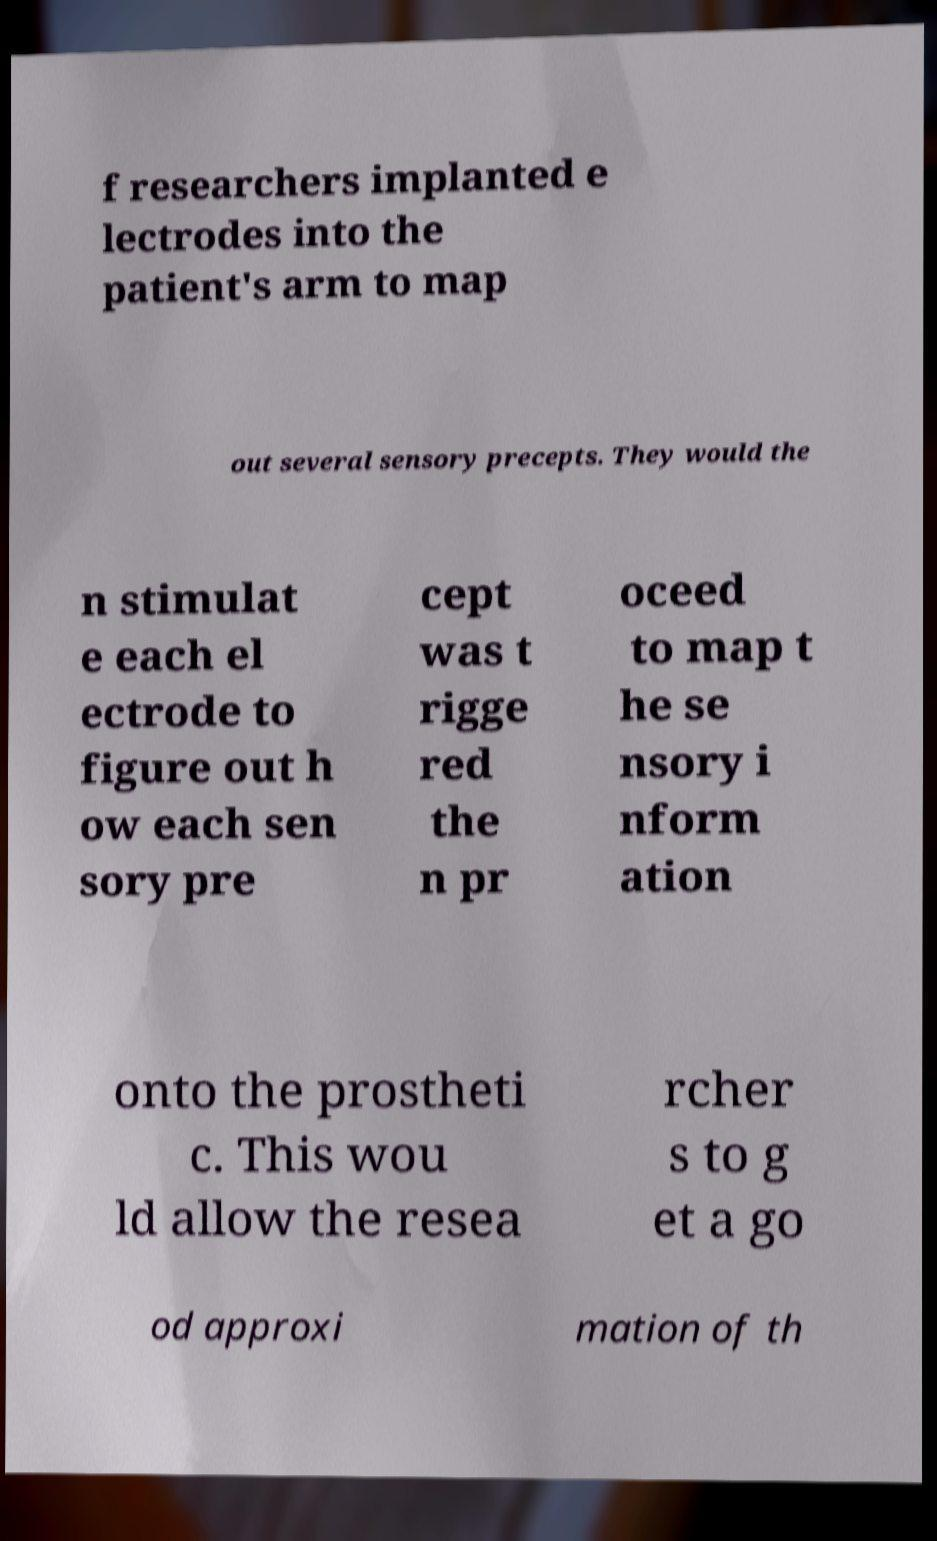Could you assist in decoding the text presented in this image and type it out clearly? f researchers implanted e lectrodes into the patient's arm to map out several sensory precepts. They would the n stimulat e each el ectrode to figure out h ow each sen sory pre cept was t rigge red the n pr oceed to map t he se nsory i nform ation onto the prostheti c. This wou ld allow the resea rcher s to g et a go od approxi mation of th 